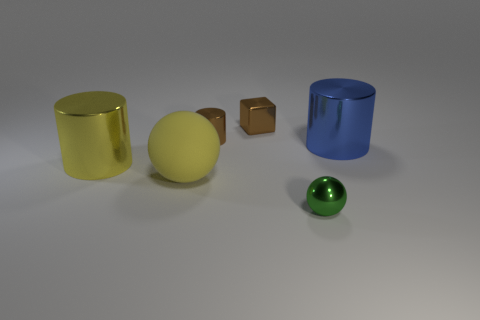Subtract all blue cylinders. How many cylinders are left? 2 Add 2 large red rubber spheres. How many objects exist? 8 Subtract 1 spheres. How many spheres are left? 1 Subtract all yellow cylinders. How many cylinders are left? 2 Subtract all cubes. How many objects are left? 5 Subtract 1 yellow balls. How many objects are left? 5 Subtract all yellow cubes. Subtract all red cylinders. How many cubes are left? 1 Subtract all red cylinders. How many green balls are left? 1 Subtract all small metallic balls. Subtract all big gray rubber cylinders. How many objects are left? 5 Add 5 yellow shiny cylinders. How many yellow shiny cylinders are left? 6 